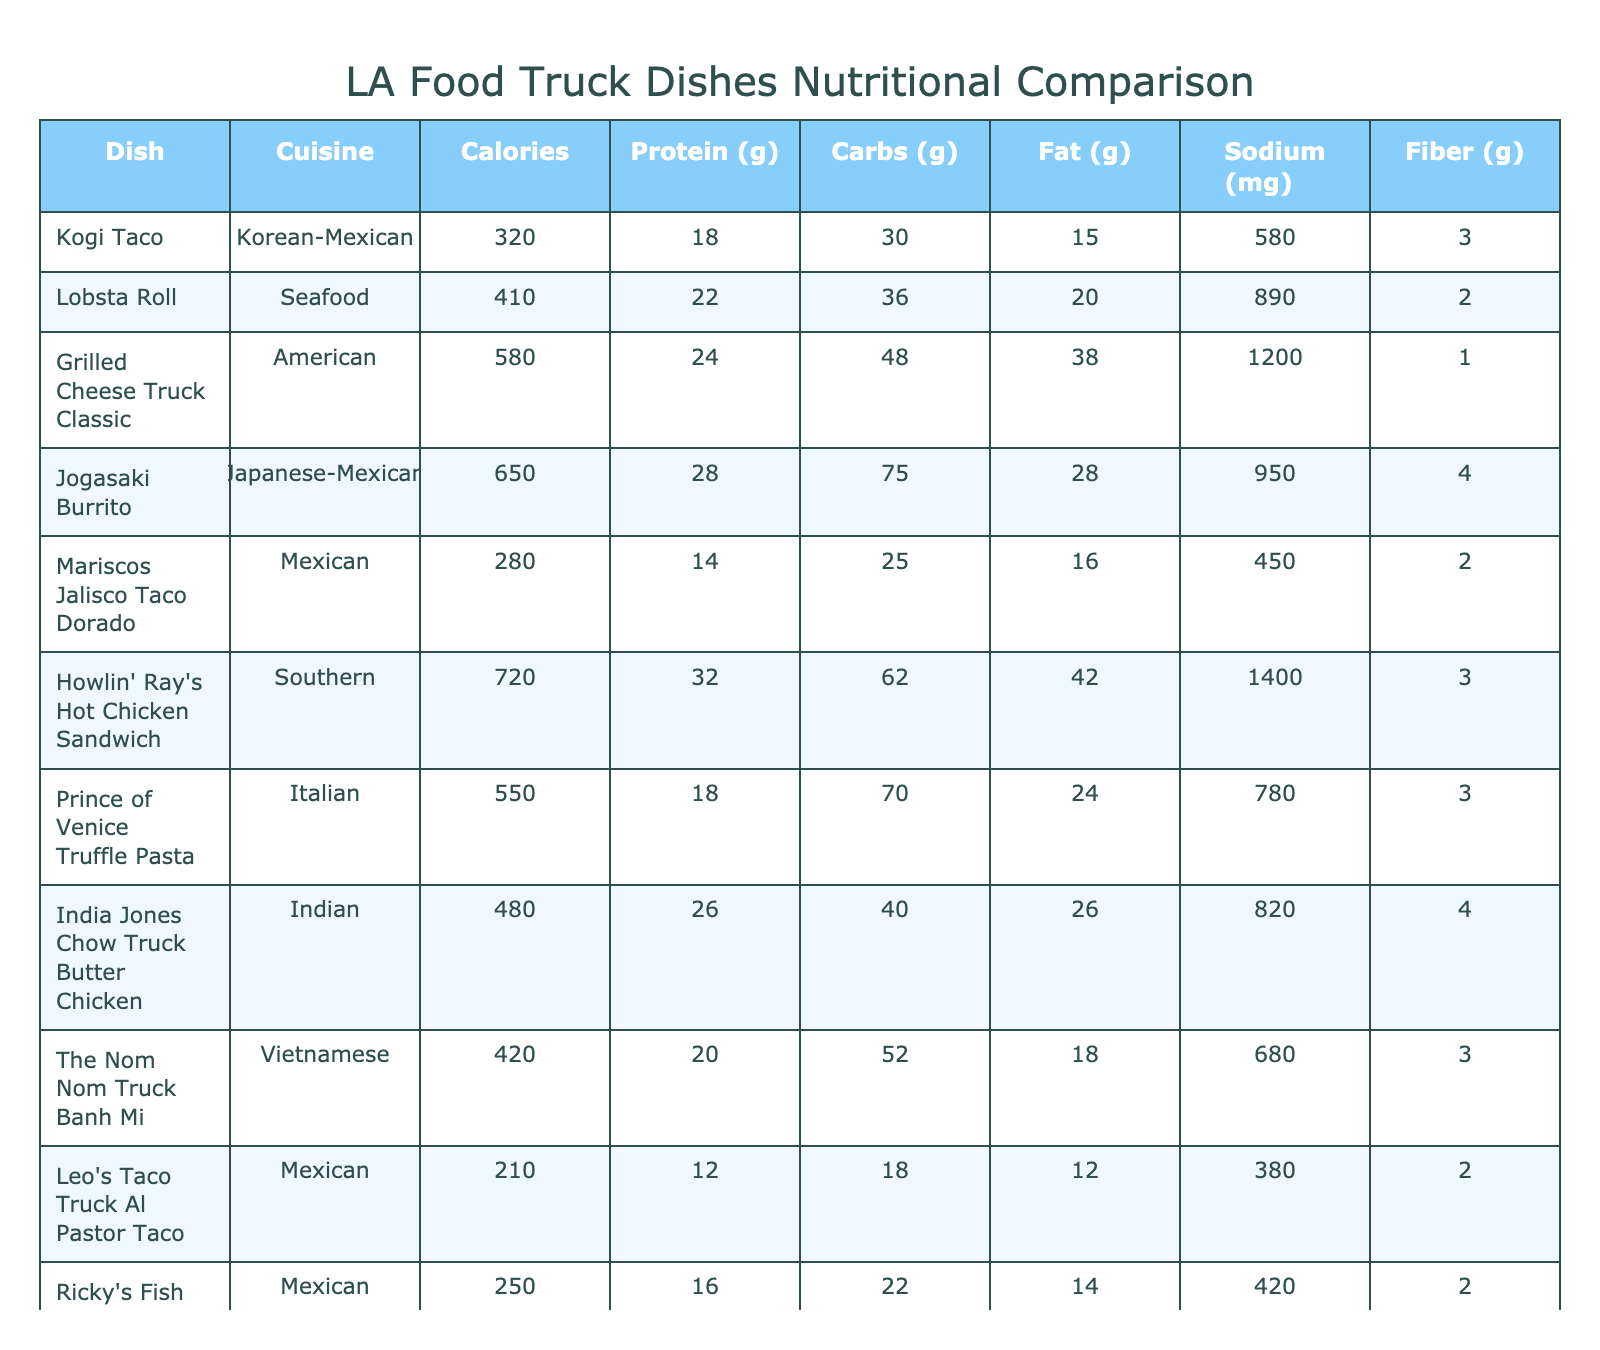What is the dish with the highest calorie count? Scanning through the "Calories" column, the dish with the highest calorie value is "Howlin' Ray's Hot Chicken Sandwich" with 720 calories.
Answer: Howlin' Ray's Hot Chicken Sandwich Which dish has the lowest amount of protein? Reviewing the "Protein (g)" column, the dish "Guerrilla Tacos Sweet Potato Taco" has the lowest protein content with 6 grams.
Answer: Guerrilla Tacos Sweet Potato Taco What is the average carbohydrate content across all dishes? Adding up the carbohydrate values (30 + 36 + 48 + 75 + 25 + 62 + 70 + 40 + 52 + 18 + 22 + 28 + 48 + 38) gives  584 grams. There are 14 dishes, so the average is 584/14 ≈ 41.71 grams.
Answer: Approximately 41.71 grams Is the sodium content of Kogi Taco less than 600 mg? Checking the "Sodium (mg)" column, Kogi Taco contains 580 mg of sodium, which is indeed less than 600 mg.
Answer: Yes How many dishes have more than 500 calories? Counting the dishes with calorie counts over 500, we find "Grilled Cheese Truck Classic" (580), "Jogasaki Burrito" (650), "Howlin' Ray's Hot Chicken Sandwich" (720), and "Prince of Venice Truffle Pasta" (550), totaling 4 dishes.
Answer: 4 Which cuisine has the highest average protein content? To find this, we sum the protein contents for each cuisine: Korean-Mexican (18), Seafood (22), American (24), Japanese-Mexican (28), Mexican (14 + 16 + 12 + 16 = 58, average is 19.33), Italian (18), Indian (26), Vietnamese (20), and Fusion (6). Calculating average for each gives: Japanese-Mexican 28, Indian 26, Southern 32, and American 24. The highest is Southern with a 32 g average for "Howlin' Ray's".
Answer: Southern What is the difference in fat content between the dish with the highest fat and the one with the lowest fat? The highest fat content is in "Grilled Cheese Truck Classic" with 38 grams and the lowest is "Guerrilla Tacos Sweet Potato Taco" with 8 grams. The difference is 38 - 8 = 30 grams.
Answer: 30 grams Do any dishes contain exactly 2 grams of fiber? Looking through the "Fiber (g)" column, we see that "Lobsta Roll", "Eggslut Bacon Egg & Cheese Sandwich", and others contain 2 grams of fiber, meaning yes, there are dishes with exactly 2 grams of fiber.
Answer: Yes What is the highest sodium content among all dishes? From the "Sodium (mg)" column, the highest value is 1400 mg, found in "Howlin' Ray's Hot Chicken Sandwich."
Answer: 1400 mg Which dish has the highest ratio of protein to calories? To find the highest ratio, we calculate protein per calorie for each dish. "Howlin' Ray's" has 32/720 = 0.0444, "Kogi Taco" has 18/320 = 0.0562, and others are calculated similarly. The highest is "Guerrilla Tacos Sweet Potato Taco" at 6/180 = 0.0333.
Answer: Kogi Taco 